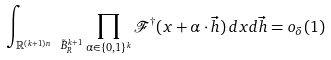<formula> <loc_0><loc_0><loc_500><loc_500>\int _ { \mathbb { R } ^ { ( k + 1 ) n } \ \tilde { B } _ { R } ^ { k + 1 } } \prod _ { \alpha \in \{ 0 , 1 \} ^ { k } } \mathcal { F } ^ { \dagger } ( x + \alpha \cdot \vec { h } ) \, d x d \vec { h } = o _ { \delta } ( 1 )</formula> 